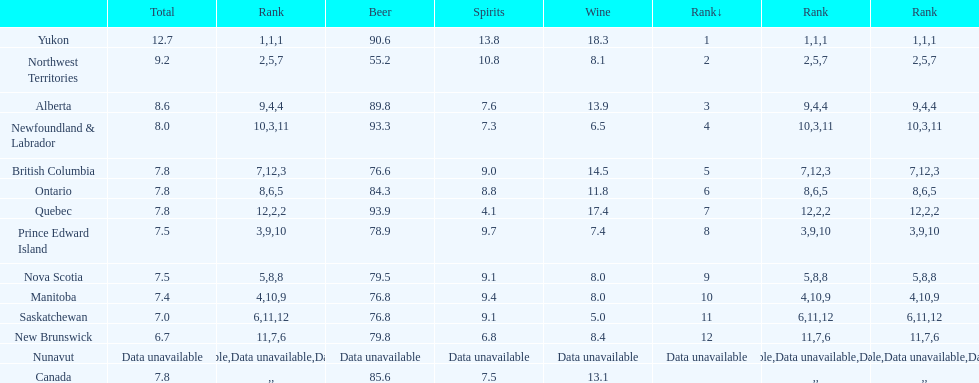Tell me province that drank more than 15 liters of wine. Yukon, Quebec. 